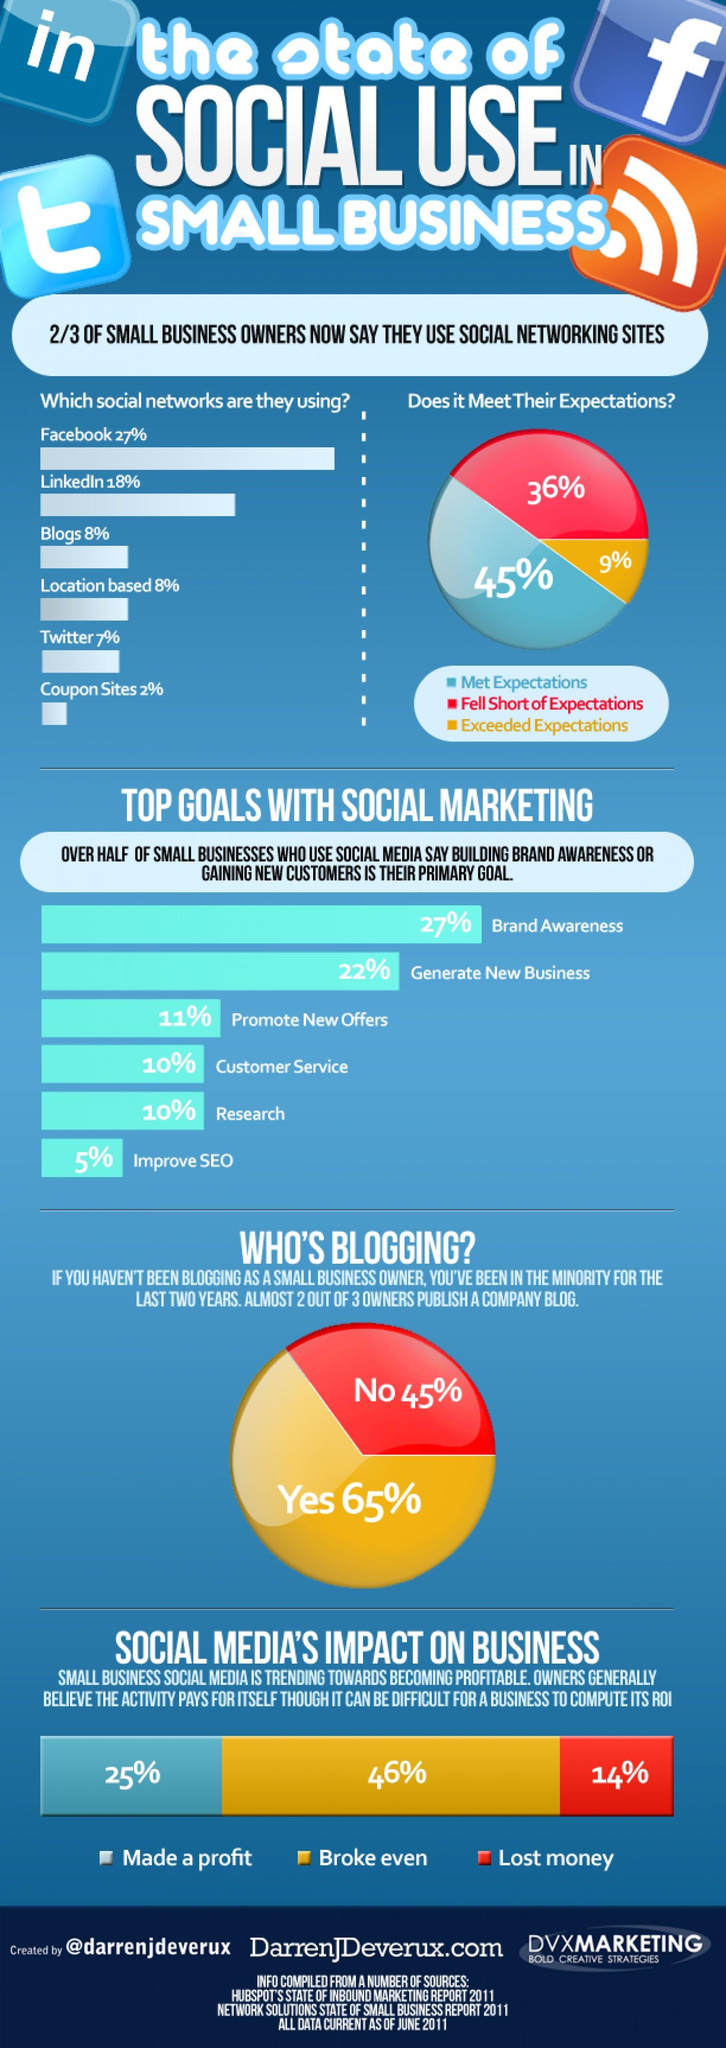Identify some key points in this picture. According to the provided information, Facebook and LinkedIn account for approximately 45% of the social networks used by small business owners. Social marketing aims to generate new business by focusing on the second top goal. According to a study, 25% of small business owners have reported making a profit through social media. According to a survey of business owners, only 9% believe that social networking sites have exceeded their expectations. 